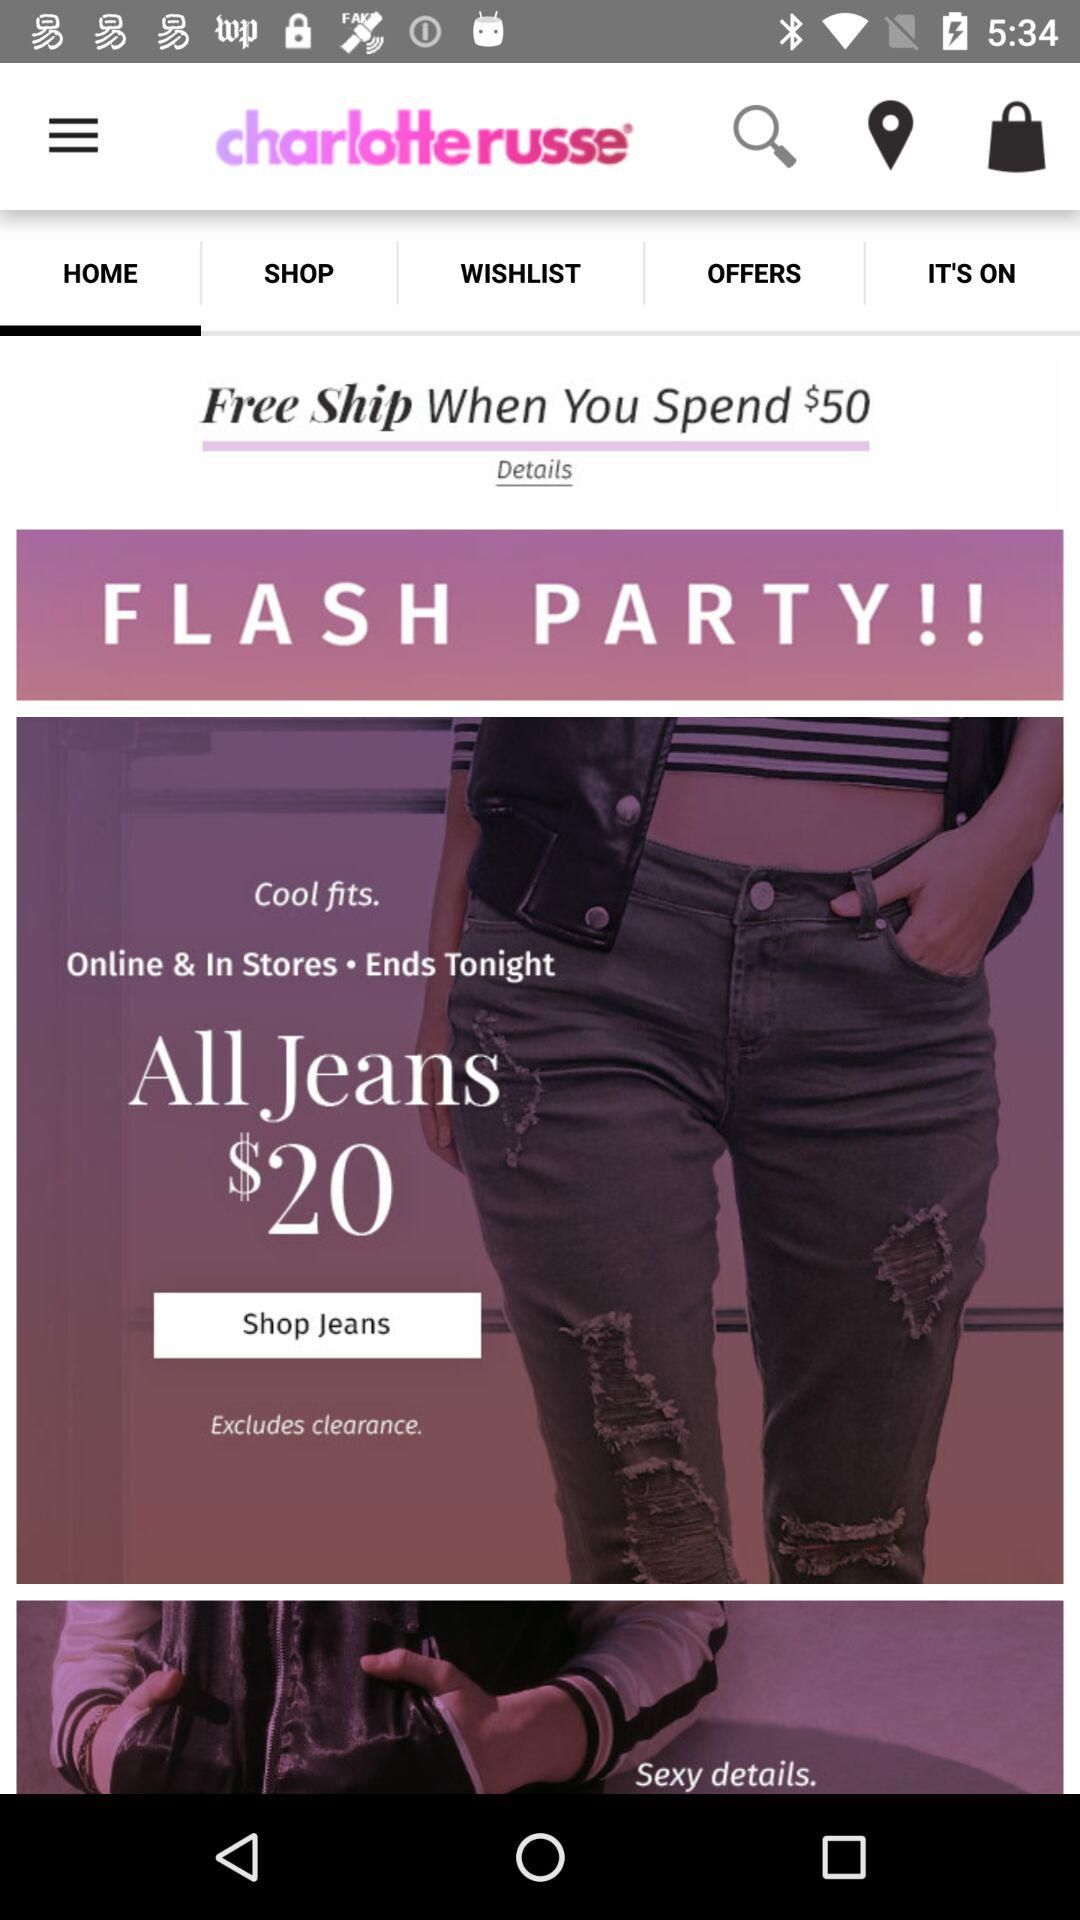What is the application name? The application name is "charlotte russe". 